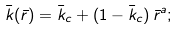Convert formula to latex. <formula><loc_0><loc_0><loc_500><loc_500>\bar { k } ( \bar { r } ) = \bar { k } _ { c } + ( 1 - \bar { k } _ { c } ) \, \bar { r } ^ { a } ;</formula> 